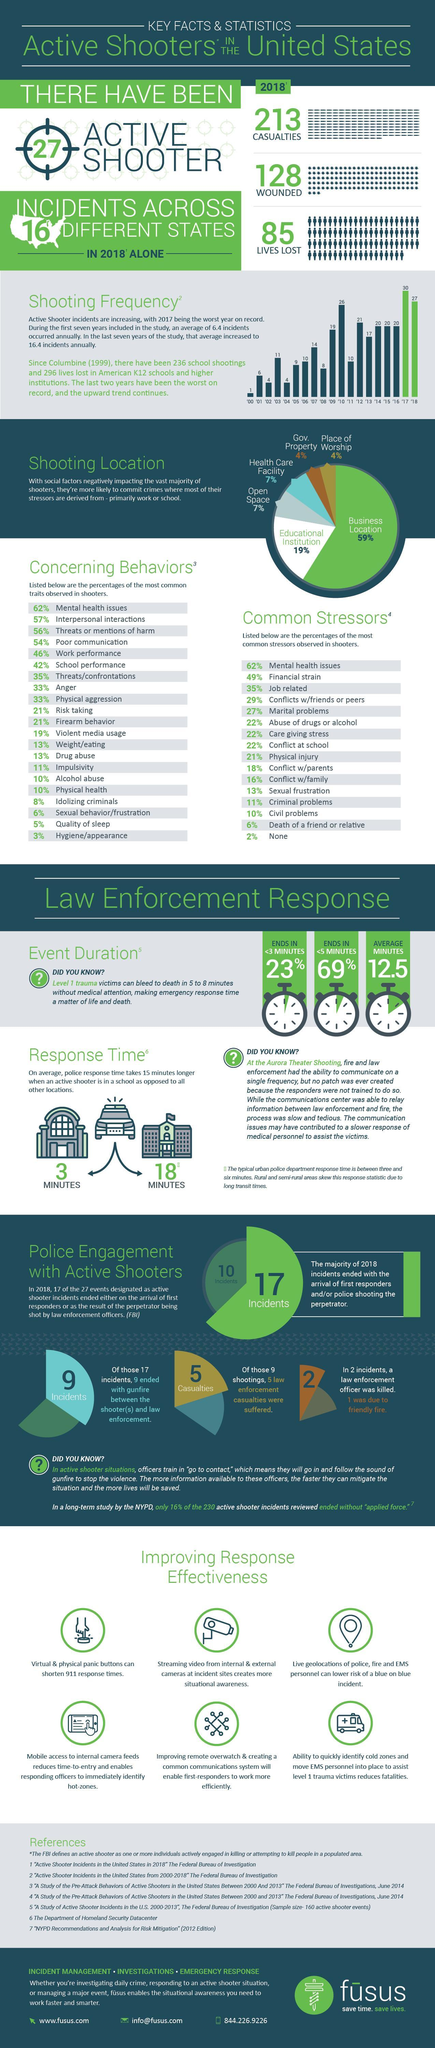which is the second highest common stressors
Answer the question with a short phrase. financial strain After business location, where is the shooting rate high educational institution how much does anger and physical aggression contribute to shooting traits 33% which is the second lowest concerning behavior quality of sleep how much does conflict at school and abuse of drugs or alcohol contribute to stressors 22% which  year was the shooting frequency 6 '01 what percentage of shooting happens in govt. property and place of workship 8 which year was the shooting frequency third highest '10 How many have been wounded or lost lives 213 what is the response time in a school 18 minutes 